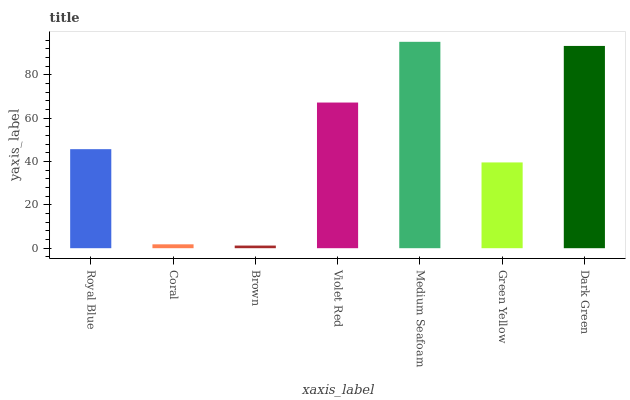Is Brown the minimum?
Answer yes or no. Yes. Is Medium Seafoam the maximum?
Answer yes or no. Yes. Is Coral the minimum?
Answer yes or no. No. Is Coral the maximum?
Answer yes or no. No. Is Royal Blue greater than Coral?
Answer yes or no. Yes. Is Coral less than Royal Blue?
Answer yes or no. Yes. Is Coral greater than Royal Blue?
Answer yes or no. No. Is Royal Blue less than Coral?
Answer yes or no. No. Is Royal Blue the high median?
Answer yes or no. Yes. Is Royal Blue the low median?
Answer yes or no. Yes. Is Green Yellow the high median?
Answer yes or no. No. Is Green Yellow the low median?
Answer yes or no. No. 